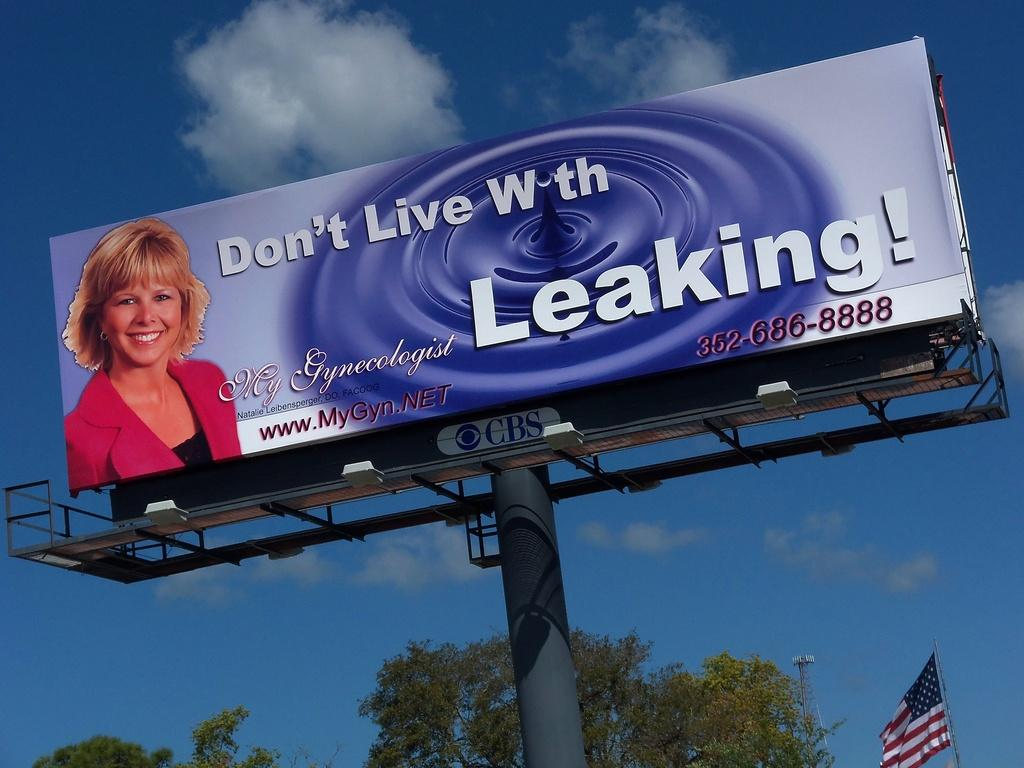<image>
Render a clear and concise summary of the photo. The billboard ad has a phone number, "352-686-8888," printed on the bottom right side. 